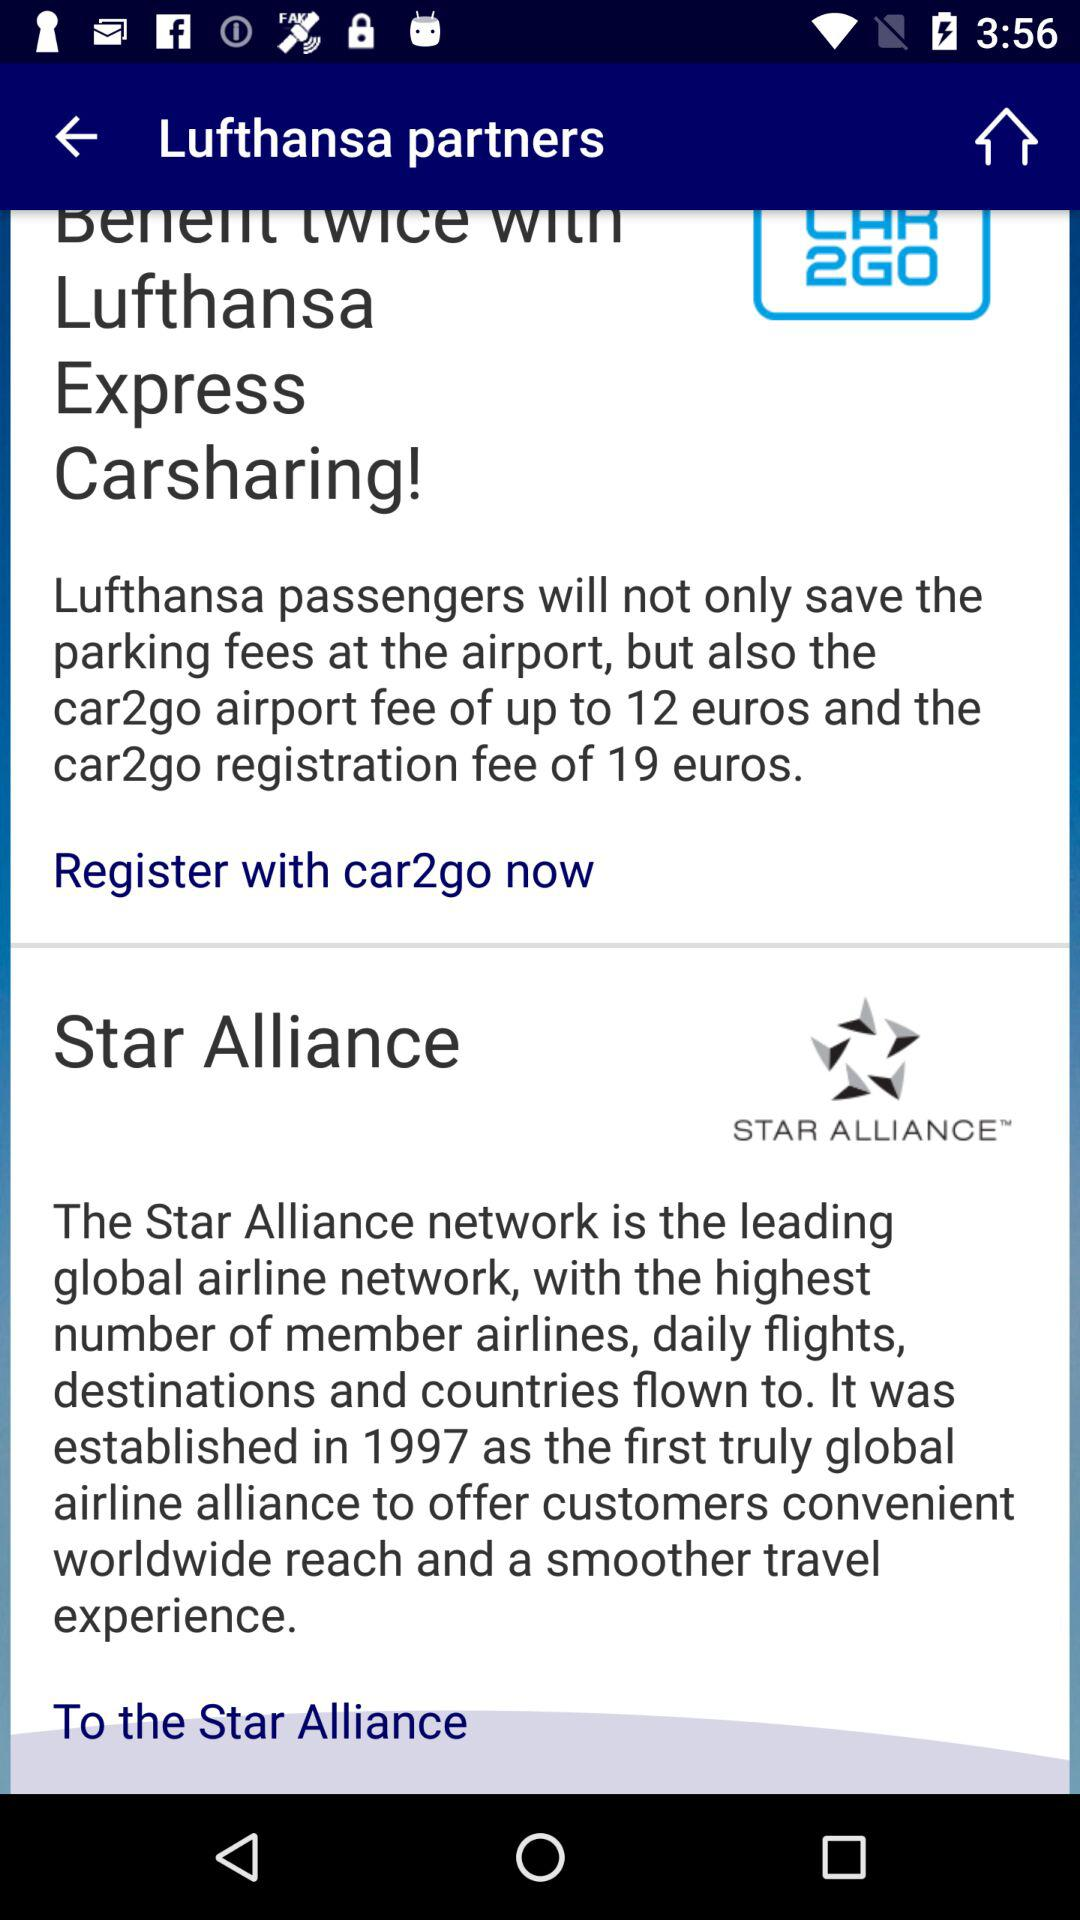Which types of personal information are required to register with "car2go"?
When the provided information is insufficient, respond with <no answer>. <no answer> 